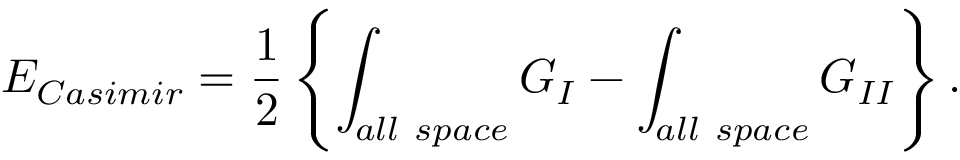Convert formula to latex. <formula><loc_0><loc_0><loc_500><loc_500>E _ { C a s i m i r } = { \frac { 1 } { 2 } } \left \{ \int _ { a l l s p a c e } G _ { I } - \int _ { a l l s p a c e } G _ { I I } \right \} .</formula> 